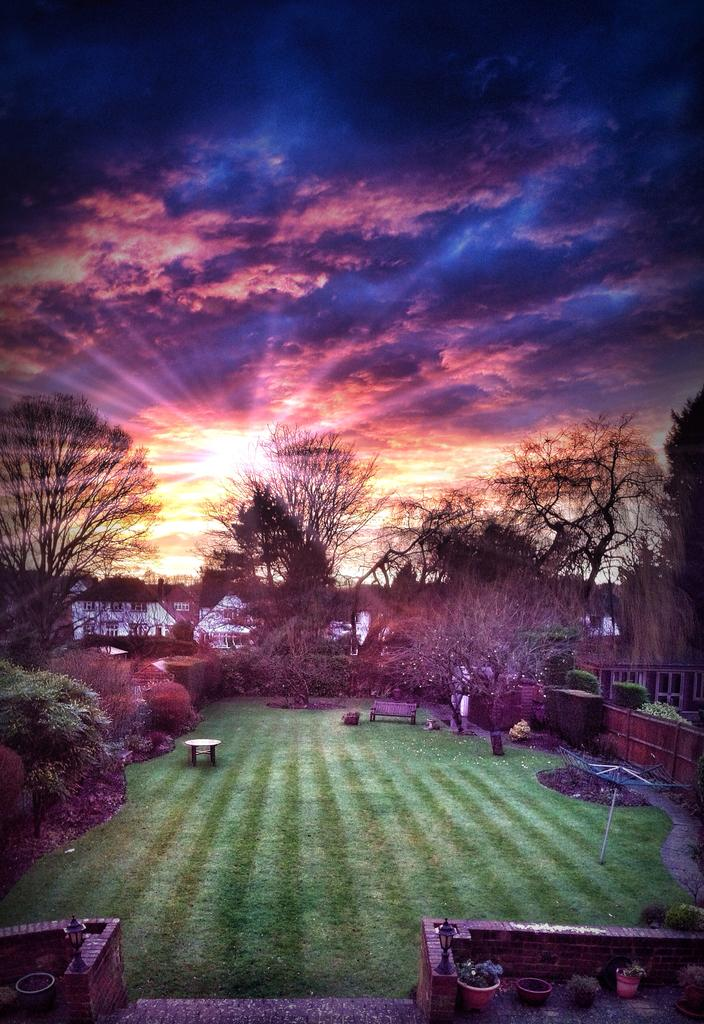What type of vegetation can be seen in the image? There are trees, plants, and grass visible in the image. What are the plant pots used for in the image? The plant pots are used to hold plants on the ground. What other objects can be seen on the ground in the image? There are other objects on the ground, but their specific nature is not mentioned in the facts. What is visible in the background of the image? The sky, the sun, and possibly other objects are visible in the background of the image. What time is displayed on the clock in the image? There is no clock present in the image, so it is not possible to determine the time. 